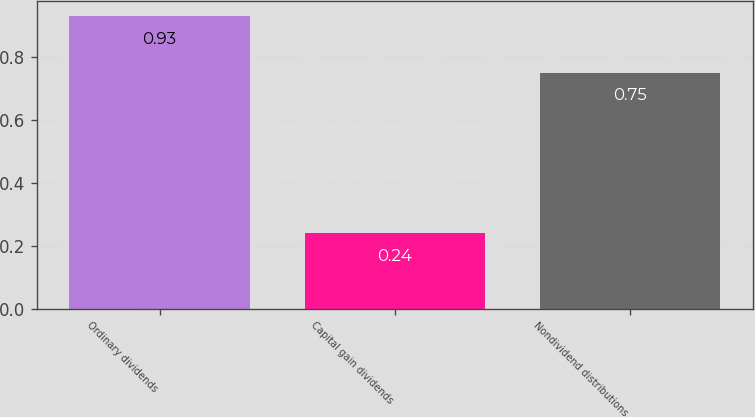Convert chart. <chart><loc_0><loc_0><loc_500><loc_500><bar_chart><fcel>Ordinary dividends<fcel>Capital gain dividends<fcel>Nondividend distributions<nl><fcel>0.93<fcel>0.24<fcel>0.75<nl></chart> 